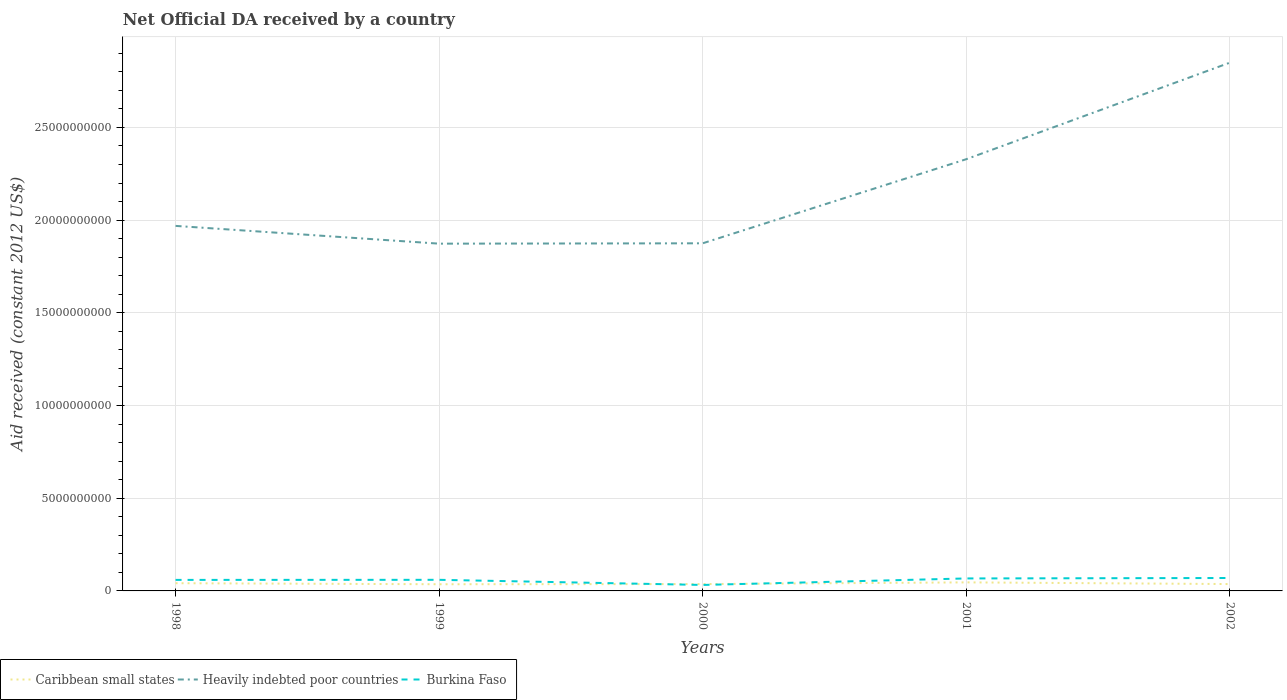Does the line corresponding to Heavily indebted poor countries intersect with the line corresponding to Burkina Faso?
Keep it short and to the point. No. Is the number of lines equal to the number of legend labels?
Offer a very short reply. Yes. Across all years, what is the maximum net official development assistance aid received in Caribbean small states?
Make the answer very short. 3.60e+08. In which year was the net official development assistance aid received in Heavily indebted poor countries maximum?
Keep it short and to the point. 1999. What is the total net official development assistance aid received in Caribbean small states in the graph?
Keep it short and to the point. 4.65e+07. What is the difference between the highest and the second highest net official development assistance aid received in Heavily indebted poor countries?
Your answer should be very brief. 9.76e+09. How many lines are there?
Offer a very short reply. 3. What is the difference between two consecutive major ticks on the Y-axis?
Your answer should be compact. 5.00e+09. How many legend labels are there?
Make the answer very short. 3. What is the title of the graph?
Ensure brevity in your answer.  Net Official DA received by a country. What is the label or title of the Y-axis?
Keep it short and to the point. Aid received (constant 2012 US$). What is the Aid received (constant 2012 US$) of Caribbean small states in 1998?
Offer a very short reply. 4.16e+08. What is the Aid received (constant 2012 US$) in Heavily indebted poor countries in 1998?
Keep it short and to the point. 1.97e+1. What is the Aid received (constant 2012 US$) of Burkina Faso in 1998?
Offer a terse response. 5.95e+08. What is the Aid received (constant 2012 US$) of Caribbean small states in 1999?
Your answer should be very brief. 3.60e+08. What is the Aid received (constant 2012 US$) of Heavily indebted poor countries in 1999?
Provide a succinct answer. 1.87e+1. What is the Aid received (constant 2012 US$) in Burkina Faso in 1999?
Your answer should be very brief. 5.99e+08. What is the Aid received (constant 2012 US$) of Caribbean small states in 2000?
Your answer should be compact. 3.70e+08. What is the Aid received (constant 2012 US$) in Heavily indebted poor countries in 2000?
Your answer should be compact. 1.87e+1. What is the Aid received (constant 2012 US$) in Burkina Faso in 2000?
Your answer should be compact. 3.22e+08. What is the Aid received (constant 2012 US$) of Caribbean small states in 2001?
Provide a short and direct response. 4.61e+08. What is the Aid received (constant 2012 US$) in Heavily indebted poor countries in 2001?
Keep it short and to the point. 2.33e+1. What is the Aid received (constant 2012 US$) in Burkina Faso in 2001?
Ensure brevity in your answer.  6.73e+08. What is the Aid received (constant 2012 US$) in Caribbean small states in 2002?
Offer a very short reply. 3.70e+08. What is the Aid received (constant 2012 US$) in Heavily indebted poor countries in 2002?
Offer a terse response. 2.85e+1. What is the Aid received (constant 2012 US$) of Burkina Faso in 2002?
Offer a very short reply. 6.97e+08. Across all years, what is the maximum Aid received (constant 2012 US$) in Caribbean small states?
Make the answer very short. 4.61e+08. Across all years, what is the maximum Aid received (constant 2012 US$) of Heavily indebted poor countries?
Offer a very short reply. 2.85e+1. Across all years, what is the maximum Aid received (constant 2012 US$) in Burkina Faso?
Provide a short and direct response. 6.97e+08. Across all years, what is the minimum Aid received (constant 2012 US$) in Caribbean small states?
Offer a terse response. 3.60e+08. Across all years, what is the minimum Aid received (constant 2012 US$) in Heavily indebted poor countries?
Offer a very short reply. 1.87e+1. Across all years, what is the minimum Aid received (constant 2012 US$) in Burkina Faso?
Your answer should be very brief. 3.22e+08. What is the total Aid received (constant 2012 US$) in Caribbean small states in the graph?
Your answer should be compact. 1.98e+09. What is the total Aid received (constant 2012 US$) in Heavily indebted poor countries in the graph?
Give a very brief answer. 1.09e+11. What is the total Aid received (constant 2012 US$) of Burkina Faso in the graph?
Ensure brevity in your answer.  2.89e+09. What is the difference between the Aid received (constant 2012 US$) of Caribbean small states in 1998 and that in 1999?
Keep it short and to the point. 5.61e+07. What is the difference between the Aid received (constant 2012 US$) in Heavily indebted poor countries in 1998 and that in 1999?
Offer a terse response. 9.58e+08. What is the difference between the Aid received (constant 2012 US$) of Burkina Faso in 1998 and that in 1999?
Make the answer very short. -4.38e+06. What is the difference between the Aid received (constant 2012 US$) of Caribbean small states in 1998 and that in 2000?
Your response must be concise. 4.65e+07. What is the difference between the Aid received (constant 2012 US$) in Heavily indebted poor countries in 1998 and that in 2000?
Offer a terse response. 9.39e+08. What is the difference between the Aid received (constant 2012 US$) in Burkina Faso in 1998 and that in 2000?
Keep it short and to the point. 2.73e+08. What is the difference between the Aid received (constant 2012 US$) of Caribbean small states in 1998 and that in 2001?
Give a very brief answer. -4.50e+07. What is the difference between the Aid received (constant 2012 US$) of Heavily indebted poor countries in 1998 and that in 2001?
Provide a short and direct response. -3.60e+09. What is the difference between the Aid received (constant 2012 US$) of Burkina Faso in 1998 and that in 2001?
Your answer should be very brief. -7.84e+07. What is the difference between the Aid received (constant 2012 US$) of Caribbean small states in 1998 and that in 2002?
Offer a terse response. 4.61e+07. What is the difference between the Aid received (constant 2012 US$) of Heavily indebted poor countries in 1998 and that in 2002?
Your answer should be compact. -8.80e+09. What is the difference between the Aid received (constant 2012 US$) in Burkina Faso in 1998 and that in 2002?
Offer a terse response. -1.02e+08. What is the difference between the Aid received (constant 2012 US$) in Caribbean small states in 1999 and that in 2000?
Your answer should be very brief. -9.65e+06. What is the difference between the Aid received (constant 2012 US$) of Heavily indebted poor countries in 1999 and that in 2000?
Your answer should be compact. -1.89e+07. What is the difference between the Aid received (constant 2012 US$) of Burkina Faso in 1999 and that in 2000?
Offer a very short reply. 2.77e+08. What is the difference between the Aid received (constant 2012 US$) of Caribbean small states in 1999 and that in 2001?
Keep it short and to the point. -1.01e+08. What is the difference between the Aid received (constant 2012 US$) of Heavily indebted poor countries in 1999 and that in 2001?
Provide a short and direct response. -4.55e+09. What is the difference between the Aid received (constant 2012 US$) of Burkina Faso in 1999 and that in 2001?
Make the answer very short. -7.41e+07. What is the difference between the Aid received (constant 2012 US$) in Caribbean small states in 1999 and that in 2002?
Make the answer very short. -1.00e+07. What is the difference between the Aid received (constant 2012 US$) of Heavily indebted poor countries in 1999 and that in 2002?
Provide a short and direct response. -9.76e+09. What is the difference between the Aid received (constant 2012 US$) in Burkina Faso in 1999 and that in 2002?
Make the answer very short. -9.80e+07. What is the difference between the Aid received (constant 2012 US$) in Caribbean small states in 2000 and that in 2001?
Make the answer very short. -9.14e+07. What is the difference between the Aid received (constant 2012 US$) in Heavily indebted poor countries in 2000 and that in 2001?
Make the answer very short. -4.54e+09. What is the difference between the Aid received (constant 2012 US$) in Burkina Faso in 2000 and that in 2001?
Your response must be concise. -3.51e+08. What is the difference between the Aid received (constant 2012 US$) in Caribbean small states in 2000 and that in 2002?
Your answer should be compact. -3.70e+05. What is the difference between the Aid received (constant 2012 US$) of Heavily indebted poor countries in 2000 and that in 2002?
Ensure brevity in your answer.  -9.74e+09. What is the difference between the Aid received (constant 2012 US$) in Burkina Faso in 2000 and that in 2002?
Make the answer very short. -3.75e+08. What is the difference between the Aid received (constant 2012 US$) in Caribbean small states in 2001 and that in 2002?
Offer a very short reply. 9.11e+07. What is the difference between the Aid received (constant 2012 US$) in Heavily indebted poor countries in 2001 and that in 2002?
Provide a short and direct response. -5.21e+09. What is the difference between the Aid received (constant 2012 US$) of Burkina Faso in 2001 and that in 2002?
Your answer should be very brief. -2.39e+07. What is the difference between the Aid received (constant 2012 US$) of Caribbean small states in 1998 and the Aid received (constant 2012 US$) of Heavily indebted poor countries in 1999?
Make the answer very short. -1.83e+1. What is the difference between the Aid received (constant 2012 US$) in Caribbean small states in 1998 and the Aid received (constant 2012 US$) in Burkina Faso in 1999?
Offer a very short reply. -1.83e+08. What is the difference between the Aid received (constant 2012 US$) of Heavily indebted poor countries in 1998 and the Aid received (constant 2012 US$) of Burkina Faso in 1999?
Offer a very short reply. 1.91e+1. What is the difference between the Aid received (constant 2012 US$) in Caribbean small states in 1998 and the Aid received (constant 2012 US$) in Heavily indebted poor countries in 2000?
Ensure brevity in your answer.  -1.83e+1. What is the difference between the Aid received (constant 2012 US$) of Caribbean small states in 1998 and the Aid received (constant 2012 US$) of Burkina Faso in 2000?
Your answer should be compact. 9.45e+07. What is the difference between the Aid received (constant 2012 US$) in Heavily indebted poor countries in 1998 and the Aid received (constant 2012 US$) in Burkina Faso in 2000?
Offer a very short reply. 1.94e+1. What is the difference between the Aid received (constant 2012 US$) in Caribbean small states in 1998 and the Aid received (constant 2012 US$) in Heavily indebted poor countries in 2001?
Your response must be concise. -2.29e+1. What is the difference between the Aid received (constant 2012 US$) of Caribbean small states in 1998 and the Aid received (constant 2012 US$) of Burkina Faso in 2001?
Offer a terse response. -2.57e+08. What is the difference between the Aid received (constant 2012 US$) of Heavily indebted poor countries in 1998 and the Aid received (constant 2012 US$) of Burkina Faso in 2001?
Ensure brevity in your answer.  1.90e+1. What is the difference between the Aid received (constant 2012 US$) in Caribbean small states in 1998 and the Aid received (constant 2012 US$) in Heavily indebted poor countries in 2002?
Keep it short and to the point. -2.81e+1. What is the difference between the Aid received (constant 2012 US$) of Caribbean small states in 1998 and the Aid received (constant 2012 US$) of Burkina Faso in 2002?
Offer a terse response. -2.81e+08. What is the difference between the Aid received (constant 2012 US$) of Heavily indebted poor countries in 1998 and the Aid received (constant 2012 US$) of Burkina Faso in 2002?
Provide a short and direct response. 1.90e+1. What is the difference between the Aid received (constant 2012 US$) in Caribbean small states in 1999 and the Aid received (constant 2012 US$) in Heavily indebted poor countries in 2000?
Make the answer very short. -1.84e+1. What is the difference between the Aid received (constant 2012 US$) in Caribbean small states in 1999 and the Aid received (constant 2012 US$) in Burkina Faso in 2000?
Make the answer very short. 3.83e+07. What is the difference between the Aid received (constant 2012 US$) in Heavily indebted poor countries in 1999 and the Aid received (constant 2012 US$) in Burkina Faso in 2000?
Make the answer very short. 1.84e+1. What is the difference between the Aid received (constant 2012 US$) of Caribbean small states in 1999 and the Aid received (constant 2012 US$) of Heavily indebted poor countries in 2001?
Your response must be concise. -2.29e+1. What is the difference between the Aid received (constant 2012 US$) of Caribbean small states in 1999 and the Aid received (constant 2012 US$) of Burkina Faso in 2001?
Give a very brief answer. -3.13e+08. What is the difference between the Aid received (constant 2012 US$) of Heavily indebted poor countries in 1999 and the Aid received (constant 2012 US$) of Burkina Faso in 2001?
Keep it short and to the point. 1.81e+1. What is the difference between the Aid received (constant 2012 US$) of Caribbean small states in 1999 and the Aid received (constant 2012 US$) of Heavily indebted poor countries in 2002?
Offer a very short reply. -2.81e+1. What is the difference between the Aid received (constant 2012 US$) of Caribbean small states in 1999 and the Aid received (constant 2012 US$) of Burkina Faso in 2002?
Offer a very short reply. -3.37e+08. What is the difference between the Aid received (constant 2012 US$) in Heavily indebted poor countries in 1999 and the Aid received (constant 2012 US$) in Burkina Faso in 2002?
Ensure brevity in your answer.  1.80e+1. What is the difference between the Aid received (constant 2012 US$) of Caribbean small states in 2000 and the Aid received (constant 2012 US$) of Heavily indebted poor countries in 2001?
Provide a short and direct response. -2.29e+1. What is the difference between the Aid received (constant 2012 US$) of Caribbean small states in 2000 and the Aid received (constant 2012 US$) of Burkina Faso in 2001?
Keep it short and to the point. -3.03e+08. What is the difference between the Aid received (constant 2012 US$) in Heavily indebted poor countries in 2000 and the Aid received (constant 2012 US$) in Burkina Faso in 2001?
Offer a terse response. 1.81e+1. What is the difference between the Aid received (constant 2012 US$) of Caribbean small states in 2000 and the Aid received (constant 2012 US$) of Heavily indebted poor countries in 2002?
Keep it short and to the point. -2.81e+1. What is the difference between the Aid received (constant 2012 US$) in Caribbean small states in 2000 and the Aid received (constant 2012 US$) in Burkina Faso in 2002?
Ensure brevity in your answer.  -3.27e+08. What is the difference between the Aid received (constant 2012 US$) of Heavily indebted poor countries in 2000 and the Aid received (constant 2012 US$) of Burkina Faso in 2002?
Provide a succinct answer. 1.81e+1. What is the difference between the Aid received (constant 2012 US$) of Caribbean small states in 2001 and the Aid received (constant 2012 US$) of Heavily indebted poor countries in 2002?
Your response must be concise. -2.80e+1. What is the difference between the Aid received (constant 2012 US$) in Caribbean small states in 2001 and the Aid received (constant 2012 US$) in Burkina Faso in 2002?
Your answer should be very brief. -2.36e+08. What is the difference between the Aid received (constant 2012 US$) of Heavily indebted poor countries in 2001 and the Aid received (constant 2012 US$) of Burkina Faso in 2002?
Offer a terse response. 2.26e+1. What is the average Aid received (constant 2012 US$) in Caribbean small states per year?
Your response must be concise. 3.96e+08. What is the average Aid received (constant 2012 US$) in Heavily indebted poor countries per year?
Give a very brief answer. 2.18e+1. What is the average Aid received (constant 2012 US$) in Burkina Faso per year?
Offer a very short reply. 5.77e+08. In the year 1998, what is the difference between the Aid received (constant 2012 US$) of Caribbean small states and Aid received (constant 2012 US$) of Heavily indebted poor countries?
Make the answer very short. -1.93e+1. In the year 1998, what is the difference between the Aid received (constant 2012 US$) of Caribbean small states and Aid received (constant 2012 US$) of Burkina Faso?
Provide a succinct answer. -1.78e+08. In the year 1998, what is the difference between the Aid received (constant 2012 US$) in Heavily indebted poor countries and Aid received (constant 2012 US$) in Burkina Faso?
Ensure brevity in your answer.  1.91e+1. In the year 1999, what is the difference between the Aid received (constant 2012 US$) in Caribbean small states and Aid received (constant 2012 US$) in Heavily indebted poor countries?
Provide a short and direct response. -1.84e+1. In the year 1999, what is the difference between the Aid received (constant 2012 US$) of Caribbean small states and Aid received (constant 2012 US$) of Burkina Faso?
Your response must be concise. -2.39e+08. In the year 1999, what is the difference between the Aid received (constant 2012 US$) of Heavily indebted poor countries and Aid received (constant 2012 US$) of Burkina Faso?
Your answer should be compact. 1.81e+1. In the year 2000, what is the difference between the Aid received (constant 2012 US$) in Caribbean small states and Aid received (constant 2012 US$) in Heavily indebted poor countries?
Ensure brevity in your answer.  -1.84e+1. In the year 2000, what is the difference between the Aid received (constant 2012 US$) in Caribbean small states and Aid received (constant 2012 US$) in Burkina Faso?
Offer a terse response. 4.80e+07. In the year 2000, what is the difference between the Aid received (constant 2012 US$) in Heavily indebted poor countries and Aid received (constant 2012 US$) in Burkina Faso?
Your answer should be very brief. 1.84e+1. In the year 2001, what is the difference between the Aid received (constant 2012 US$) in Caribbean small states and Aid received (constant 2012 US$) in Heavily indebted poor countries?
Provide a succinct answer. -2.28e+1. In the year 2001, what is the difference between the Aid received (constant 2012 US$) of Caribbean small states and Aid received (constant 2012 US$) of Burkina Faso?
Provide a short and direct response. -2.12e+08. In the year 2001, what is the difference between the Aid received (constant 2012 US$) of Heavily indebted poor countries and Aid received (constant 2012 US$) of Burkina Faso?
Ensure brevity in your answer.  2.26e+1. In the year 2002, what is the difference between the Aid received (constant 2012 US$) of Caribbean small states and Aid received (constant 2012 US$) of Heavily indebted poor countries?
Give a very brief answer. -2.81e+1. In the year 2002, what is the difference between the Aid received (constant 2012 US$) of Caribbean small states and Aid received (constant 2012 US$) of Burkina Faso?
Give a very brief answer. -3.27e+08. In the year 2002, what is the difference between the Aid received (constant 2012 US$) of Heavily indebted poor countries and Aid received (constant 2012 US$) of Burkina Faso?
Give a very brief answer. 2.78e+1. What is the ratio of the Aid received (constant 2012 US$) of Caribbean small states in 1998 to that in 1999?
Your response must be concise. 1.16. What is the ratio of the Aid received (constant 2012 US$) in Heavily indebted poor countries in 1998 to that in 1999?
Keep it short and to the point. 1.05. What is the ratio of the Aid received (constant 2012 US$) of Burkina Faso in 1998 to that in 1999?
Ensure brevity in your answer.  0.99. What is the ratio of the Aid received (constant 2012 US$) in Caribbean small states in 1998 to that in 2000?
Keep it short and to the point. 1.13. What is the ratio of the Aid received (constant 2012 US$) in Heavily indebted poor countries in 1998 to that in 2000?
Offer a terse response. 1.05. What is the ratio of the Aid received (constant 2012 US$) in Burkina Faso in 1998 to that in 2000?
Offer a terse response. 1.85. What is the ratio of the Aid received (constant 2012 US$) in Caribbean small states in 1998 to that in 2001?
Provide a short and direct response. 0.9. What is the ratio of the Aid received (constant 2012 US$) of Heavily indebted poor countries in 1998 to that in 2001?
Your answer should be very brief. 0.85. What is the ratio of the Aid received (constant 2012 US$) of Burkina Faso in 1998 to that in 2001?
Your answer should be compact. 0.88. What is the ratio of the Aid received (constant 2012 US$) of Caribbean small states in 1998 to that in 2002?
Your response must be concise. 1.12. What is the ratio of the Aid received (constant 2012 US$) in Heavily indebted poor countries in 1998 to that in 2002?
Offer a very short reply. 0.69. What is the ratio of the Aid received (constant 2012 US$) of Burkina Faso in 1998 to that in 2002?
Offer a terse response. 0.85. What is the ratio of the Aid received (constant 2012 US$) of Caribbean small states in 1999 to that in 2000?
Make the answer very short. 0.97. What is the ratio of the Aid received (constant 2012 US$) in Burkina Faso in 1999 to that in 2000?
Your answer should be very brief. 1.86. What is the ratio of the Aid received (constant 2012 US$) of Caribbean small states in 1999 to that in 2001?
Give a very brief answer. 0.78. What is the ratio of the Aid received (constant 2012 US$) in Heavily indebted poor countries in 1999 to that in 2001?
Offer a very short reply. 0.8. What is the ratio of the Aid received (constant 2012 US$) of Burkina Faso in 1999 to that in 2001?
Your response must be concise. 0.89. What is the ratio of the Aid received (constant 2012 US$) in Caribbean small states in 1999 to that in 2002?
Your answer should be compact. 0.97. What is the ratio of the Aid received (constant 2012 US$) in Heavily indebted poor countries in 1999 to that in 2002?
Your answer should be very brief. 0.66. What is the ratio of the Aid received (constant 2012 US$) of Burkina Faso in 1999 to that in 2002?
Give a very brief answer. 0.86. What is the ratio of the Aid received (constant 2012 US$) in Caribbean small states in 2000 to that in 2001?
Provide a succinct answer. 0.8. What is the ratio of the Aid received (constant 2012 US$) of Heavily indebted poor countries in 2000 to that in 2001?
Make the answer very short. 0.81. What is the ratio of the Aid received (constant 2012 US$) of Burkina Faso in 2000 to that in 2001?
Make the answer very short. 0.48. What is the ratio of the Aid received (constant 2012 US$) of Heavily indebted poor countries in 2000 to that in 2002?
Ensure brevity in your answer.  0.66. What is the ratio of the Aid received (constant 2012 US$) of Burkina Faso in 2000 to that in 2002?
Give a very brief answer. 0.46. What is the ratio of the Aid received (constant 2012 US$) in Caribbean small states in 2001 to that in 2002?
Your answer should be very brief. 1.25. What is the ratio of the Aid received (constant 2012 US$) in Heavily indebted poor countries in 2001 to that in 2002?
Give a very brief answer. 0.82. What is the ratio of the Aid received (constant 2012 US$) in Burkina Faso in 2001 to that in 2002?
Make the answer very short. 0.97. What is the difference between the highest and the second highest Aid received (constant 2012 US$) in Caribbean small states?
Provide a short and direct response. 4.50e+07. What is the difference between the highest and the second highest Aid received (constant 2012 US$) in Heavily indebted poor countries?
Make the answer very short. 5.21e+09. What is the difference between the highest and the second highest Aid received (constant 2012 US$) in Burkina Faso?
Keep it short and to the point. 2.39e+07. What is the difference between the highest and the lowest Aid received (constant 2012 US$) in Caribbean small states?
Your answer should be compact. 1.01e+08. What is the difference between the highest and the lowest Aid received (constant 2012 US$) of Heavily indebted poor countries?
Your response must be concise. 9.76e+09. What is the difference between the highest and the lowest Aid received (constant 2012 US$) in Burkina Faso?
Keep it short and to the point. 3.75e+08. 